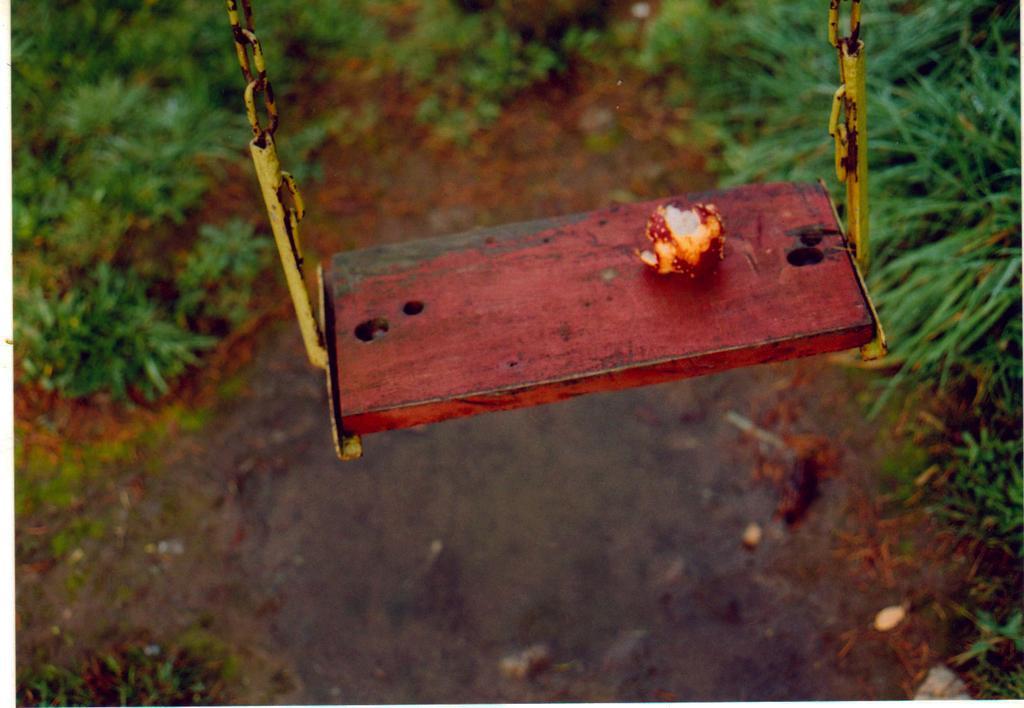Can you describe this image briefly? In this picture we can see a fruit on a swing and in the background we can see grass on the ground. 